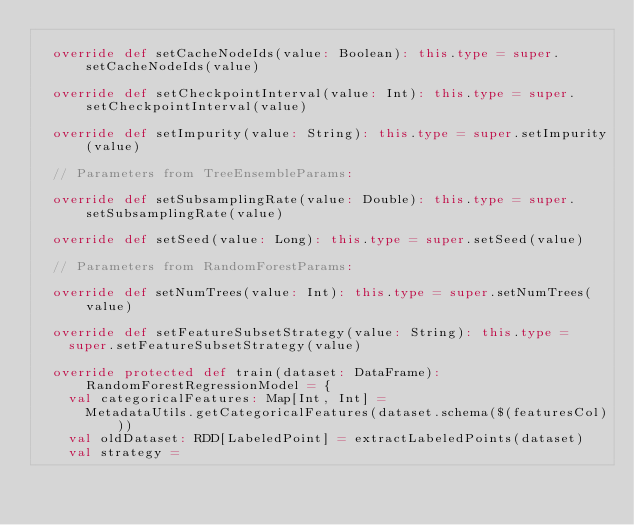Convert code to text. <code><loc_0><loc_0><loc_500><loc_500><_Scala_>
  override def setCacheNodeIds(value: Boolean): this.type = super.setCacheNodeIds(value)

  override def setCheckpointInterval(value: Int): this.type = super.setCheckpointInterval(value)

  override def setImpurity(value: String): this.type = super.setImpurity(value)

  // Parameters from TreeEnsembleParams:

  override def setSubsamplingRate(value: Double): this.type = super.setSubsamplingRate(value)

  override def setSeed(value: Long): this.type = super.setSeed(value)

  // Parameters from RandomForestParams:

  override def setNumTrees(value: Int): this.type = super.setNumTrees(value)

  override def setFeatureSubsetStrategy(value: String): this.type =
    super.setFeatureSubsetStrategy(value)

  override protected def train(dataset: DataFrame): RandomForestRegressionModel = {
    val categoricalFeatures: Map[Int, Int] =
      MetadataUtils.getCategoricalFeatures(dataset.schema($(featuresCol)))
    val oldDataset: RDD[LabeledPoint] = extractLabeledPoints(dataset)
    val strategy =</code> 